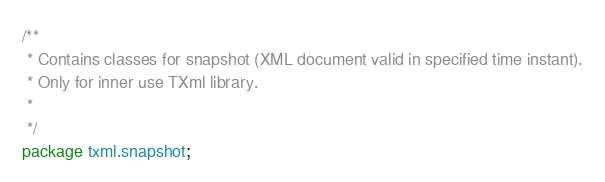<code> <loc_0><loc_0><loc_500><loc_500><_Java_>/**
 * Contains classes for snapshot (XML document valid in specified time instant).
 * Only for inner use TXml library.
 * 
 */
package txml.snapshot;
</code> 